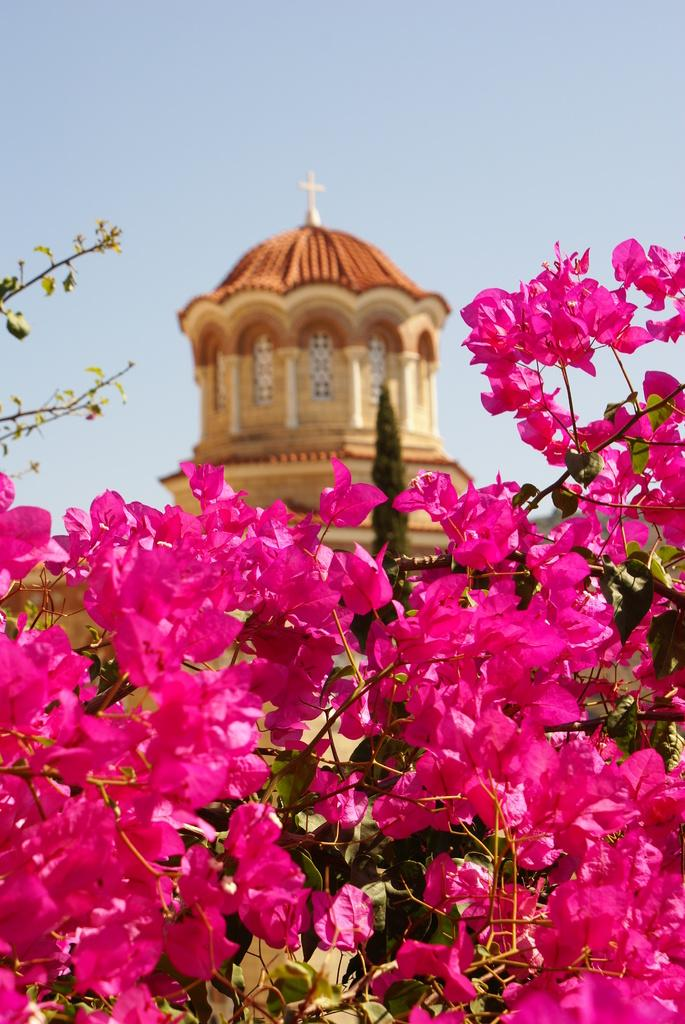Where was the picture taken? The picture was clicked outside. What can be seen in the foreground of the image? There are flowers and leaves in the foreground of the image. What is visible in the background of the image? There is sky, a tree, and a tower-like object visible in the background of the image. How does the grip of the snow affect the flowers in the image? There is no snow present in the image, so the grip of the snow cannot affect the flowers. 